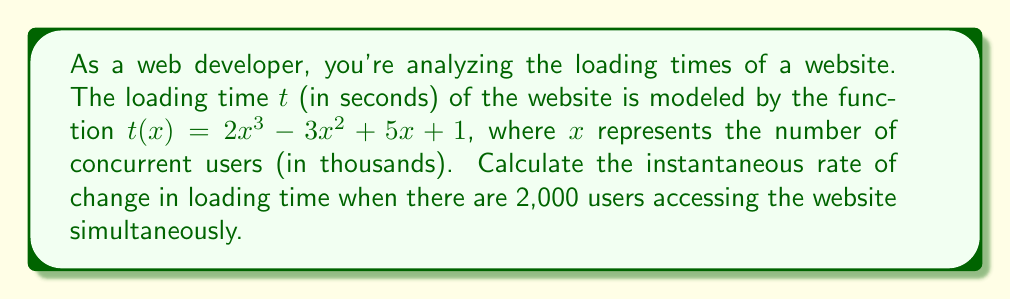Provide a solution to this math problem. To solve this problem, we need to follow these steps:

1) The instantaneous rate of change is given by the derivative of the function at a specific point.

2) First, let's find the derivative of $t(x)$:
   $$\frac{d}{dx}t(x) = \frac{d}{dx}(2x^3 - 3x^2 + 5x + 1)$$
   $$t'(x) = 6x^2 - 6x + 5$$

3) Now, we need to evaluate this derivative at $x = 2$ (since 2,000 users = 2 thousand users):
   $$t'(2) = 6(2)^2 - 6(2) + 5$$
   $$= 6(4) - 12 + 5$$
   $$= 24 - 12 + 5$$
   $$= 17$$

4) Interpret the result: The rate of change is 17 seconds per thousand users, or 0.017 seconds per user.
Answer: The instantaneous rate of change in loading time when there are 2,000 users is 17 seconds per thousand users, or 0.017 seconds per user. 